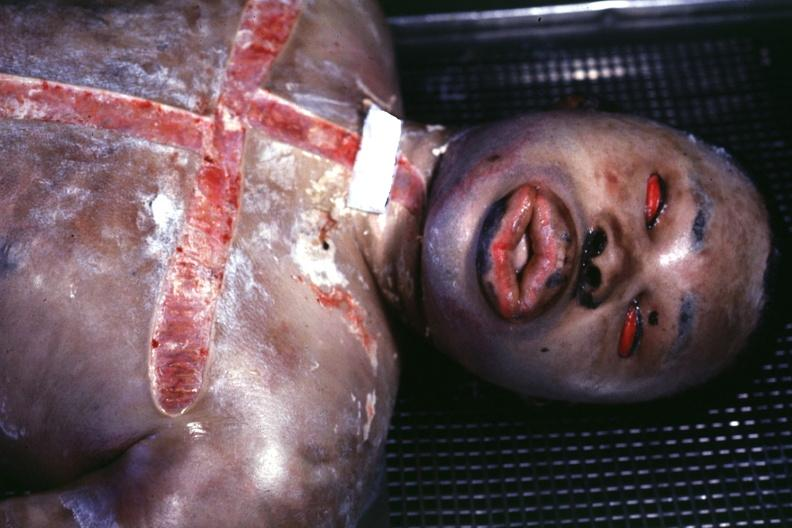what showing grotesque edema?
Answer the question using a single word or phrase. View of face 